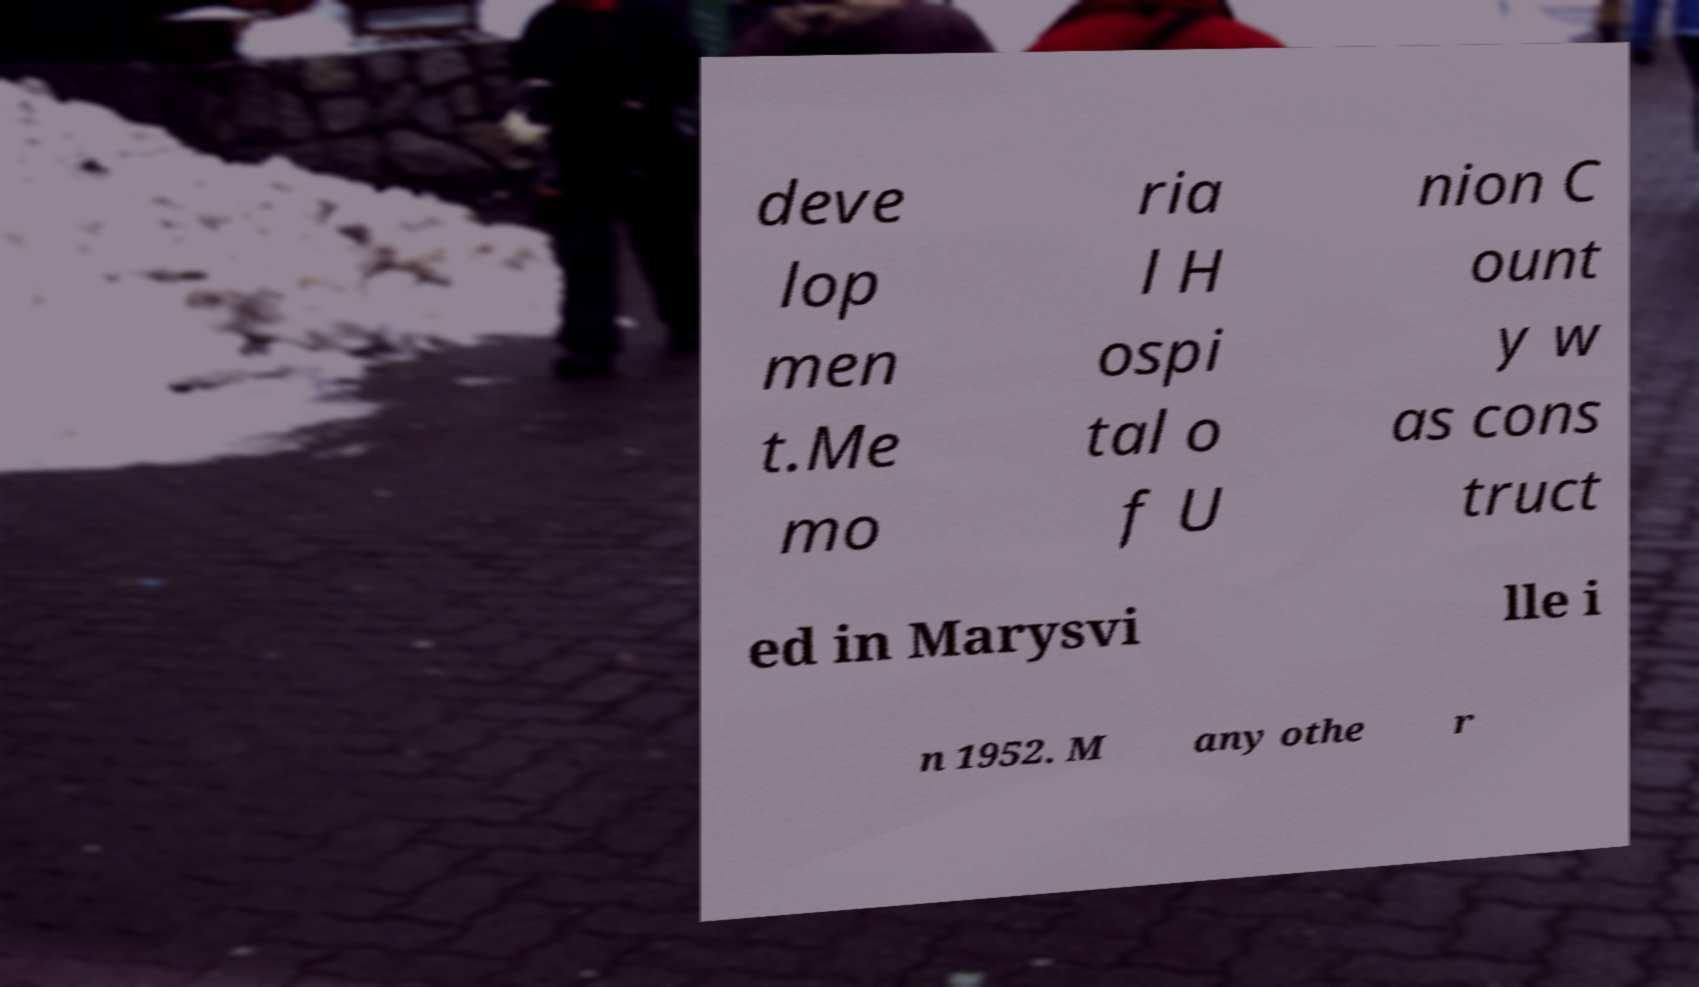Please read and relay the text visible in this image. What does it say? deve lop men t.Me mo ria l H ospi tal o f U nion C ount y w as cons truct ed in Marysvi lle i n 1952. M any othe r 